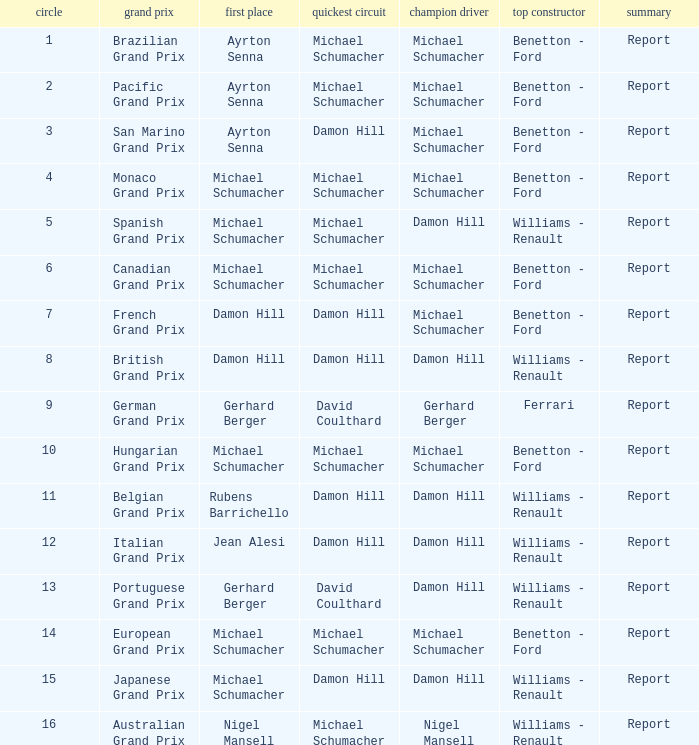Name the pole position at the japanese grand prix when the fastest lap is damon hill Michael Schumacher. 